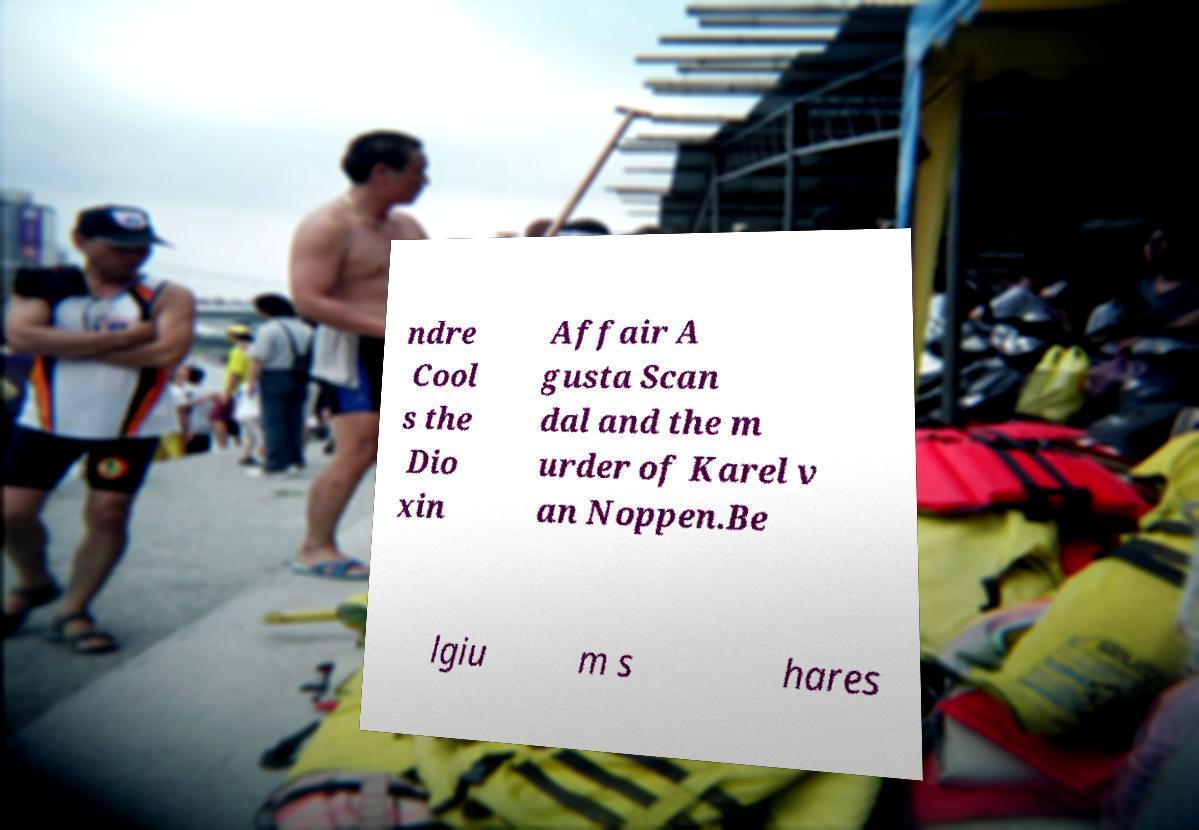There's text embedded in this image that I need extracted. Can you transcribe it verbatim? ndre Cool s the Dio xin Affair A gusta Scan dal and the m urder of Karel v an Noppen.Be lgiu m s hares 